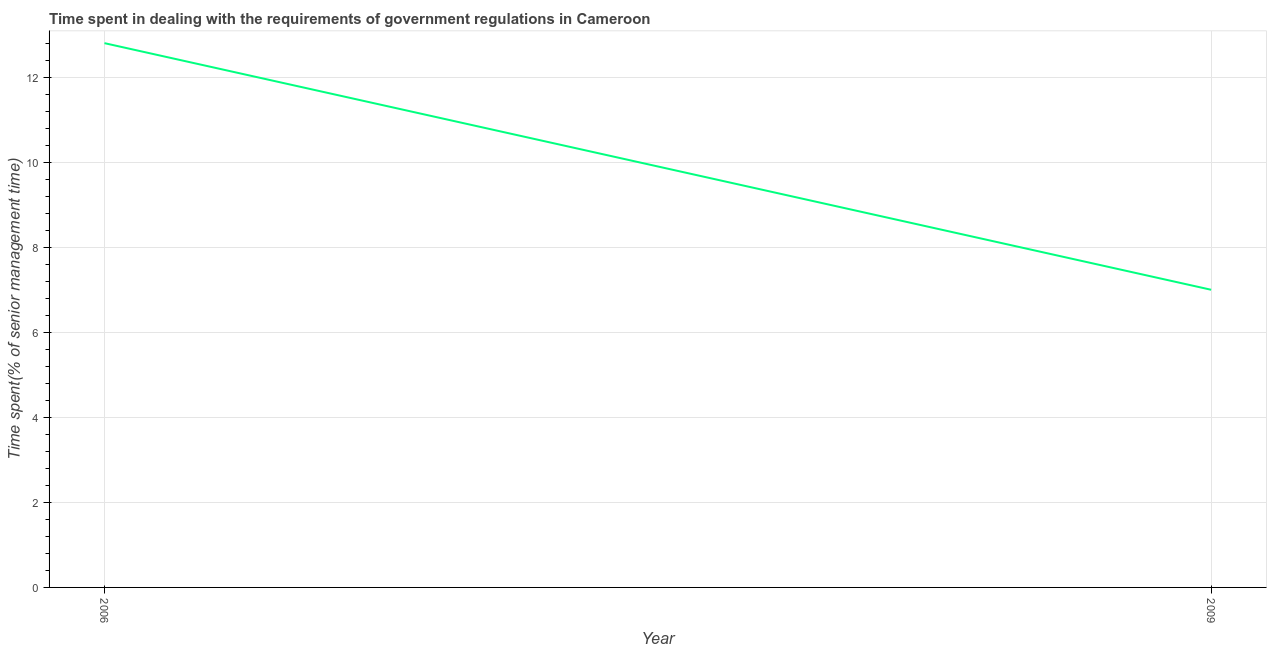Across all years, what is the maximum time spent in dealing with government regulations?
Make the answer very short. 12.8. Across all years, what is the minimum time spent in dealing with government regulations?
Offer a terse response. 7. In which year was the time spent in dealing with government regulations maximum?
Your response must be concise. 2006. In which year was the time spent in dealing with government regulations minimum?
Your answer should be very brief. 2009. What is the sum of the time spent in dealing with government regulations?
Provide a succinct answer. 19.8. What is the difference between the time spent in dealing with government regulations in 2006 and 2009?
Your answer should be compact. 5.8. What is the average time spent in dealing with government regulations per year?
Make the answer very short. 9.9. What is the median time spent in dealing with government regulations?
Make the answer very short. 9.9. In how many years, is the time spent in dealing with government regulations greater than 7.6 %?
Give a very brief answer. 1. What is the ratio of the time spent in dealing with government regulations in 2006 to that in 2009?
Make the answer very short. 1.83. Is the time spent in dealing with government regulations in 2006 less than that in 2009?
Ensure brevity in your answer.  No. In how many years, is the time spent in dealing with government regulations greater than the average time spent in dealing with government regulations taken over all years?
Provide a short and direct response. 1. Does the time spent in dealing with government regulations monotonically increase over the years?
Give a very brief answer. No. How many lines are there?
Give a very brief answer. 1. How many years are there in the graph?
Make the answer very short. 2. Does the graph contain any zero values?
Offer a terse response. No. Does the graph contain grids?
Your response must be concise. Yes. What is the title of the graph?
Keep it short and to the point. Time spent in dealing with the requirements of government regulations in Cameroon. What is the label or title of the Y-axis?
Provide a short and direct response. Time spent(% of senior management time). What is the Time spent(% of senior management time) in 2006?
Provide a succinct answer. 12.8. What is the difference between the Time spent(% of senior management time) in 2006 and 2009?
Give a very brief answer. 5.8. What is the ratio of the Time spent(% of senior management time) in 2006 to that in 2009?
Offer a terse response. 1.83. 